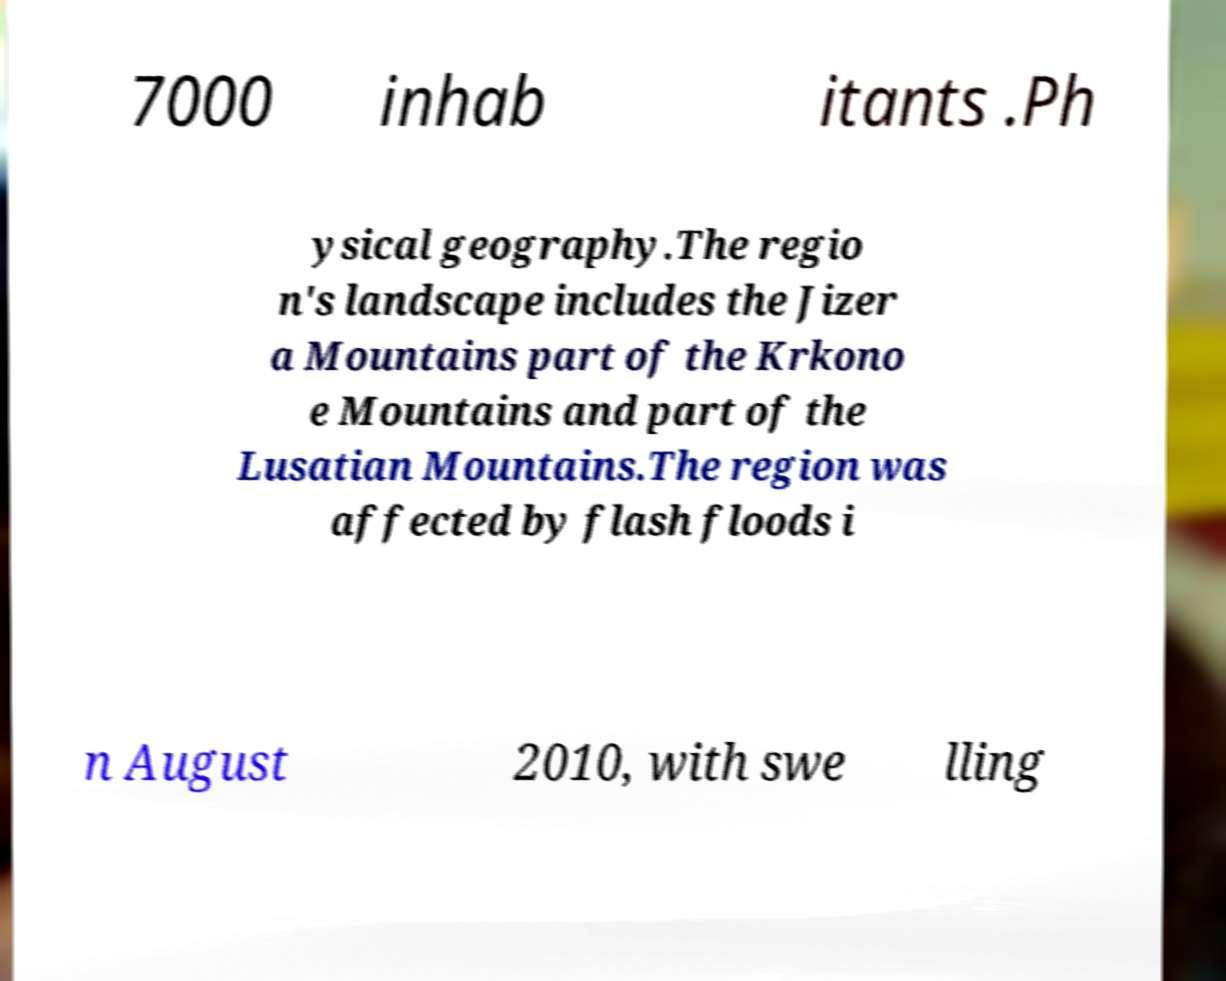For documentation purposes, I need the text within this image transcribed. Could you provide that? 7000 inhab itants .Ph ysical geography.The regio n's landscape includes the Jizer a Mountains part of the Krkono e Mountains and part of the Lusatian Mountains.The region was affected by flash floods i n August 2010, with swe lling 